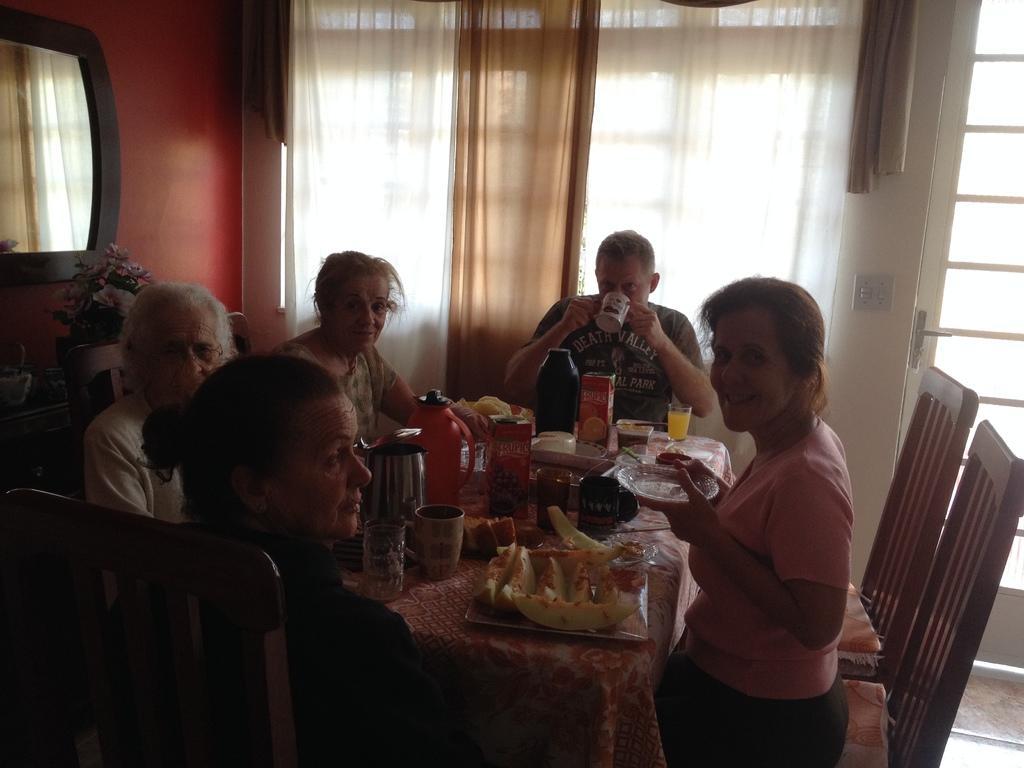In one or two sentences, can you explain what this image depicts? in this image there are people sitting around the table. on the table there are glass, kettle, food. behind them there are curtains. at the left side there is a mirror on the wall. 